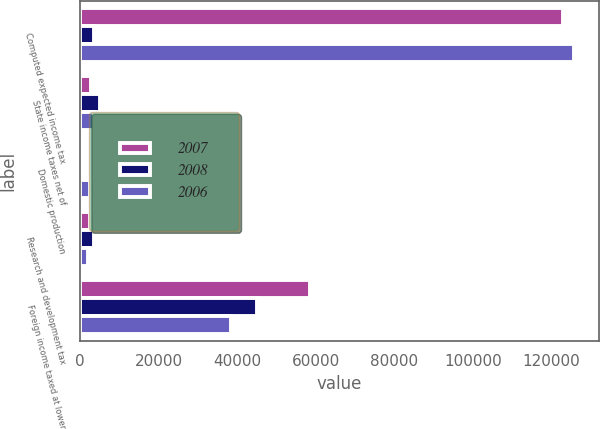<chart> <loc_0><loc_0><loc_500><loc_500><stacked_bar_chart><ecel><fcel>Computed expected income tax<fcel>State income taxes net of<fcel>Domestic production<fcel>Research and development tax<fcel>Foreign income taxed at lower<nl><fcel>2007<fcel>122845<fcel>2727<fcel>257<fcel>2625<fcel>58489<nl><fcel>2008<fcel>3560.5<fcel>5103<fcel>658<fcel>3573<fcel>44993<nl><fcel>2006<fcel>125715<fcel>3548<fcel>2600<fcel>2095<fcel>38362<nl></chart> 